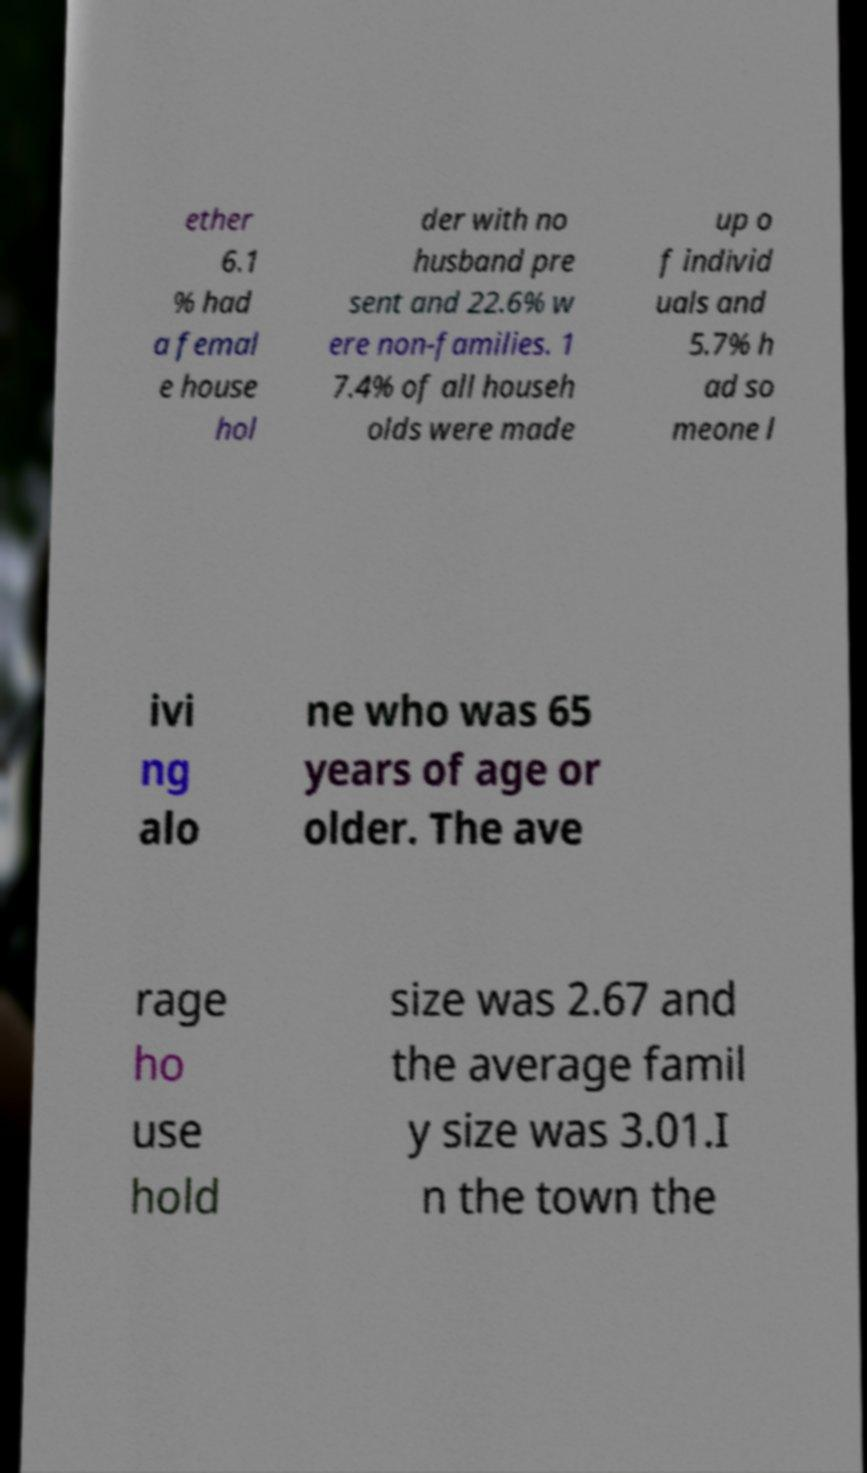What messages or text are displayed in this image? I need them in a readable, typed format. ether 6.1 % had a femal e house hol der with no husband pre sent and 22.6% w ere non-families. 1 7.4% of all househ olds were made up o f individ uals and 5.7% h ad so meone l ivi ng alo ne who was 65 years of age or older. The ave rage ho use hold size was 2.67 and the average famil y size was 3.01.I n the town the 